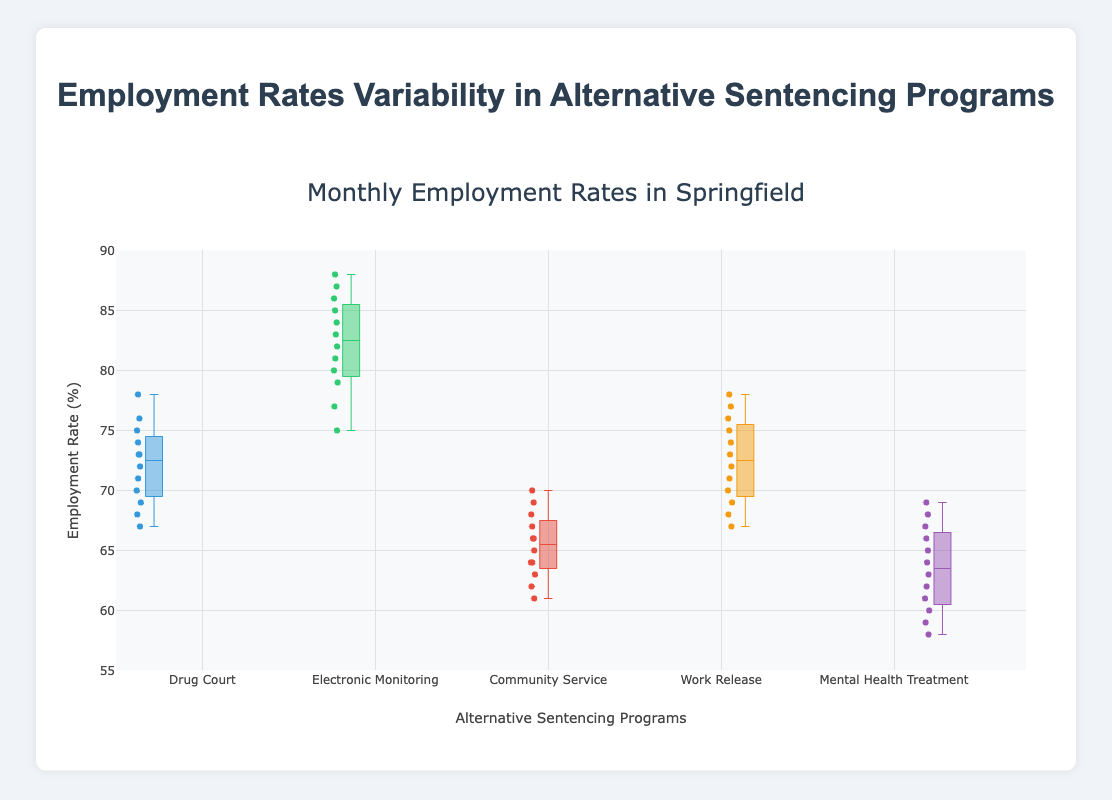How many alternative sentencing programs are shown in the plot? The plot displays separate boxes for each alternative sentencing program. You can count the number of unique program names on the x-axis to determine this.
Answer: 5 What is the y-axis range of the plot? The y-axis range indicates the minimum and maximum values shown on the y-axis. These are the lower and upper limits of the axes.
Answer: 55 to 90 Which alternative sentencing program has the highest median employment rate? Locate the median line within each boxplot and compare them. The highest median line identifies the program with the highest median employment rate.
Answer: Electronic Monitoring What's the interquartile range (IQR) for Drug Court? The IQR is calculated as the difference between the third quartile (Q3) and the first quartile (Q1). Examine the box for Drug Court to identify Q1 and Q3.
Answer: 74 - 69 = 5 Which program shows the greatest variability in monthly employment rates? Variability in box plots can be assessed by looking at the range between the lower and upper whiskers. Find the program with the largest distance between its whiskers.
Answer: Electronic Monitoring Compare the median employment rates of Community Service and Mental Health Treatment. Which is higher and by how much? Compare the median lines of the boxes for each program. Then, subtract the median of the lower program from the higher one to find the difference.
Answer: Community Service's median is higher by 4% For Work Release, what is the range between the minimum and maximum employment rates? Identify the bottom of the lower whisker and the top of the upper whisker for Work Release. Subtract the minimum value from the maximum value to get the range.
Answer: 78 - 67 = 11 Which alternative sentencing program has the least variability in employment rates? Look for the program whose box and whiskers are closest together (smallest range). This indicates the least variability.
Answer: Drug Court What is the outlier in the Community Service employment rates? Outliers are individual points that fall outside the whiskers of the box plot. Locate any points outside the whiskers for Community Service.
Answer: 61 